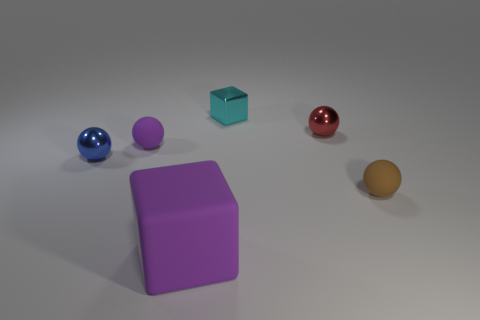Add 3 large balls. How many objects exist? 9 Subtract all green spheres. Subtract all yellow cylinders. How many spheres are left? 4 Subtract all balls. How many objects are left? 2 Add 2 tiny brown rubber things. How many tiny brown rubber things exist? 3 Subtract 0 green cylinders. How many objects are left? 6 Subtract all purple rubber things. Subtract all small purple spheres. How many objects are left? 3 Add 5 small matte balls. How many small matte balls are left? 7 